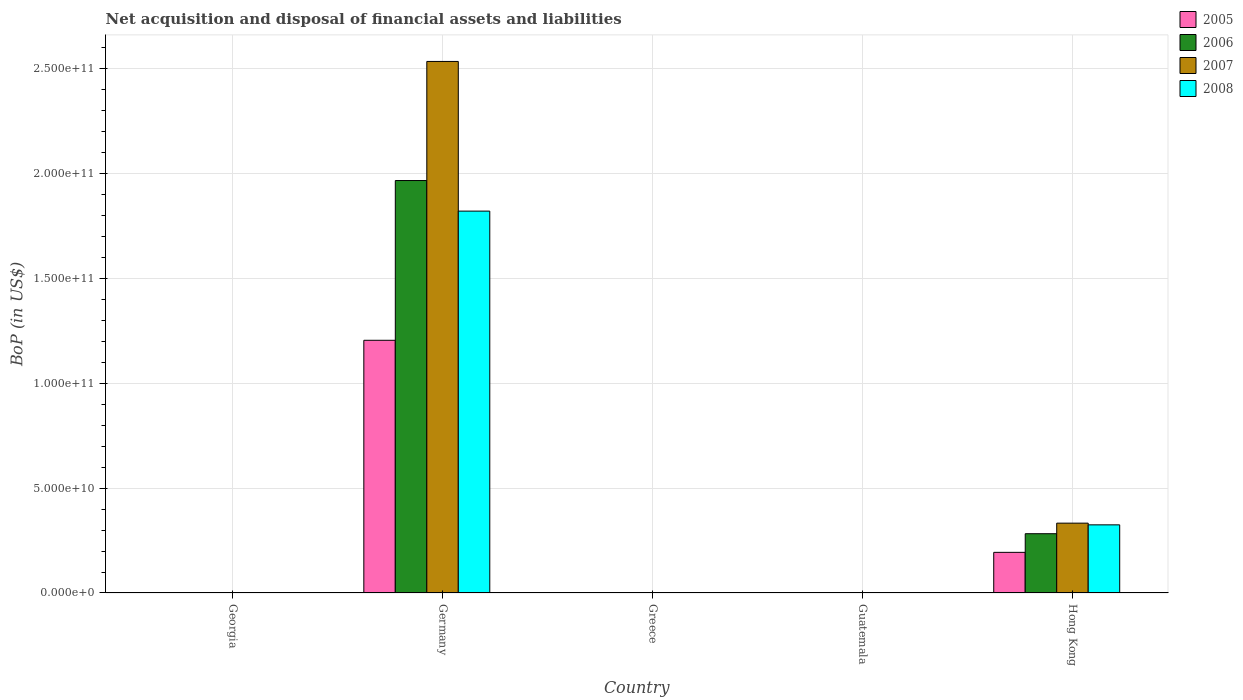How many different coloured bars are there?
Your answer should be compact. 4. Are the number of bars on each tick of the X-axis equal?
Your response must be concise. No. What is the label of the 4th group of bars from the left?
Give a very brief answer. Guatemala. What is the Balance of Payments in 2007 in Germany?
Make the answer very short. 2.53e+11. Across all countries, what is the maximum Balance of Payments in 2008?
Offer a terse response. 1.82e+11. Across all countries, what is the minimum Balance of Payments in 2007?
Your response must be concise. 0. In which country was the Balance of Payments in 2008 maximum?
Your answer should be very brief. Germany. What is the total Balance of Payments in 2008 in the graph?
Your response must be concise. 2.15e+11. What is the difference between the Balance of Payments in 2005 in Germany and the Balance of Payments in 2006 in Hong Kong?
Your answer should be very brief. 9.22e+1. What is the average Balance of Payments in 2008 per country?
Keep it short and to the point. 4.29e+1. What is the difference between the Balance of Payments of/in 2008 and Balance of Payments of/in 2005 in Germany?
Your answer should be compact. 6.16e+1. What is the ratio of the Balance of Payments in 2008 in Germany to that in Hong Kong?
Offer a terse response. 5.61. What is the difference between the highest and the lowest Balance of Payments in 2005?
Your response must be concise. 1.20e+11. In how many countries, is the Balance of Payments in 2007 greater than the average Balance of Payments in 2007 taken over all countries?
Provide a short and direct response. 1. Is it the case that in every country, the sum of the Balance of Payments in 2007 and Balance of Payments in 2005 is greater than the sum of Balance of Payments in 2008 and Balance of Payments in 2006?
Keep it short and to the point. No. Is it the case that in every country, the sum of the Balance of Payments in 2005 and Balance of Payments in 2007 is greater than the Balance of Payments in 2008?
Provide a short and direct response. No. Are all the bars in the graph horizontal?
Ensure brevity in your answer.  No. How many countries are there in the graph?
Ensure brevity in your answer.  5. What is the difference between two consecutive major ticks on the Y-axis?
Your response must be concise. 5.00e+1. Does the graph contain grids?
Offer a terse response. Yes. Where does the legend appear in the graph?
Make the answer very short. Top right. How many legend labels are there?
Keep it short and to the point. 4. How are the legend labels stacked?
Offer a terse response. Vertical. What is the title of the graph?
Provide a succinct answer. Net acquisition and disposal of financial assets and liabilities. What is the label or title of the X-axis?
Offer a very short reply. Country. What is the label or title of the Y-axis?
Offer a very short reply. BoP (in US$). What is the BoP (in US$) in 2006 in Georgia?
Your answer should be very brief. 0. What is the BoP (in US$) of 2008 in Georgia?
Your answer should be very brief. 0. What is the BoP (in US$) of 2005 in Germany?
Offer a terse response. 1.20e+11. What is the BoP (in US$) of 2006 in Germany?
Keep it short and to the point. 1.97e+11. What is the BoP (in US$) of 2007 in Germany?
Your response must be concise. 2.53e+11. What is the BoP (in US$) in 2008 in Germany?
Your response must be concise. 1.82e+11. What is the BoP (in US$) of 2005 in Greece?
Your response must be concise. 0. What is the BoP (in US$) of 2005 in Guatemala?
Ensure brevity in your answer.  0. What is the BoP (in US$) of 2006 in Guatemala?
Your answer should be compact. 0. What is the BoP (in US$) in 2008 in Guatemala?
Give a very brief answer. 0. What is the BoP (in US$) of 2005 in Hong Kong?
Ensure brevity in your answer.  1.94e+1. What is the BoP (in US$) in 2006 in Hong Kong?
Your response must be concise. 2.83e+1. What is the BoP (in US$) in 2007 in Hong Kong?
Give a very brief answer. 3.33e+1. What is the BoP (in US$) of 2008 in Hong Kong?
Offer a terse response. 3.25e+1. Across all countries, what is the maximum BoP (in US$) of 2005?
Provide a short and direct response. 1.20e+11. Across all countries, what is the maximum BoP (in US$) in 2006?
Ensure brevity in your answer.  1.97e+11. Across all countries, what is the maximum BoP (in US$) in 2007?
Provide a succinct answer. 2.53e+11. Across all countries, what is the maximum BoP (in US$) of 2008?
Provide a short and direct response. 1.82e+11. What is the total BoP (in US$) in 2005 in the graph?
Make the answer very short. 1.40e+11. What is the total BoP (in US$) in 2006 in the graph?
Provide a short and direct response. 2.25e+11. What is the total BoP (in US$) in 2007 in the graph?
Provide a succinct answer. 2.87e+11. What is the total BoP (in US$) of 2008 in the graph?
Provide a short and direct response. 2.15e+11. What is the difference between the BoP (in US$) in 2005 in Germany and that in Hong Kong?
Your response must be concise. 1.01e+11. What is the difference between the BoP (in US$) in 2006 in Germany and that in Hong Kong?
Give a very brief answer. 1.68e+11. What is the difference between the BoP (in US$) in 2007 in Germany and that in Hong Kong?
Give a very brief answer. 2.20e+11. What is the difference between the BoP (in US$) in 2008 in Germany and that in Hong Kong?
Make the answer very short. 1.50e+11. What is the difference between the BoP (in US$) of 2005 in Germany and the BoP (in US$) of 2006 in Hong Kong?
Your answer should be very brief. 9.22e+1. What is the difference between the BoP (in US$) of 2005 in Germany and the BoP (in US$) of 2007 in Hong Kong?
Provide a succinct answer. 8.72e+1. What is the difference between the BoP (in US$) in 2005 in Germany and the BoP (in US$) in 2008 in Hong Kong?
Offer a very short reply. 8.80e+1. What is the difference between the BoP (in US$) of 2006 in Germany and the BoP (in US$) of 2007 in Hong Kong?
Provide a succinct answer. 1.63e+11. What is the difference between the BoP (in US$) of 2006 in Germany and the BoP (in US$) of 2008 in Hong Kong?
Give a very brief answer. 1.64e+11. What is the difference between the BoP (in US$) in 2007 in Germany and the BoP (in US$) in 2008 in Hong Kong?
Offer a terse response. 2.21e+11. What is the average BoP (in US$) of 2005 per country?
Your response must be concise. 2.80e+1. What is the average BoP (in US$) of 2006 per country?
Make the answer very short. 4.50e+1. What is the average BoP (in US$) of 2007 per country?
Your response must be concise. 5.73e+1. What is the average BoP (in US$) in 2008 per country?
Give a very brief answer. 4.29e+1. What is the difference between the BoP (in US$) of 2005 and BoP (in US$) of 2006 in Germany?
Keep it short and to the point. -7.62e+1. What is the difference between the BoP (in US$) in 2005 and BoP (in US$) in 2007 in Germany?
Your response must be concise. -1.33e+11. What is the difference between the BoP (in US$) of 2005 and BoP (in US$) of 2008 in Germany?
Your answer should be very brief. -6.16e+1. What is the difference between the BoP (in US$) of 2006 and BoP (in US$) of 2007 in Germany?
Offer a terse response. -5.68e+1. What is the difference between the BoP (in US$) of 2006 and BoP (in US$) of 2008 in Germany?
Offer a terse response. 1.46e+1. What is the difference between the BoP (in US$) of 2007 and BoP (in US$) of 2008 in Germany?
Offer a terse response. 7.13e+1. What is the difference between the BoP (in US$) in 2005 and BoP (in US$) in 2006 in Hong Kong?
Your response must be concise. -8.89e+09. What is the difference between the BoP (in US$) in 2005 and BoP (in US$) in 2007 in Hong Kong?
Provide a short and direct response. -1.39e+1. What is the difference between the BoP (in US$) of 2005 and BoP (in US$) of 2008 in Hong Kong?
Provide a succinct answer. -1.31e+1. What is the difference between the BoP (in US$) of 2006 and BoP (in US$) of 2007 in Hong Kong?
Give a very brief answer. -5.04e+09. What is the difference between the BoP (in US$) of 2006 and BoP (in US$) of 2008 in Hong Kong?
Keep it short and to the point. -4.22e+09. What is the difference between the BoP (in US$) of 2007 and BoP (in US$) of 2008 in Hong Kong?
Make the answer very short. 8.15e+08. What is the ratio of the BoP (in US$) of 2005 in Germany to that in Hong Kong?
Your answer should be compact. 6.22. What is the ratio of the BoP (in US$) in 2006 in Germany to that in Hong Kong?
Give a very brief answer. 6.96. What is the ratio of the BoP (in US$) of 2007 in Germany to that in Hong Kong?
Your response must be concise. 7.61. What is the ratio of the BoP (in US$) of 2008 in Germany to that in Hong Kong?
Ensure brevity in your answer.  5.61. What is the difference between the highest and the lowest BoP (in US$) in 2005?
Keep it short and to the point. 1.20e+11. What is the difference between the highest and the lowest BoP (in US$) of 2006?
Ensure brevity in your answer.  1.97e+11. What is the difference between the highest and the lowest BoP (in US$) of 2007?
Keep it short and to the point. 2.53e+11. What is the difference between the highest and the lowest BoP (in US$) in 2008?
Keep it short and to the point. 1.82e+11. 